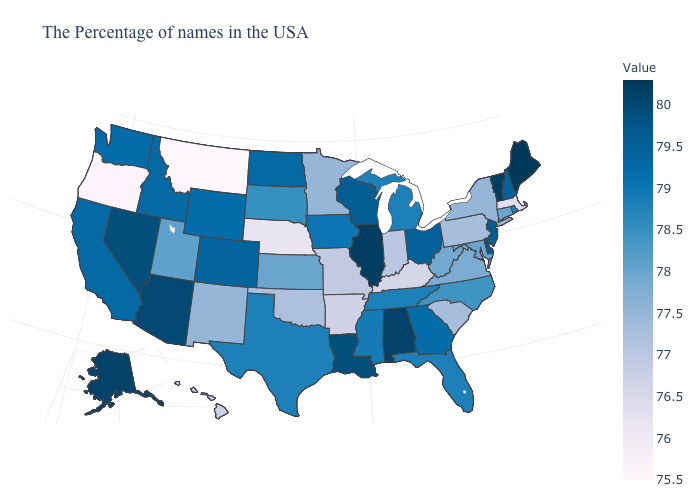Is the legend a continuous bar?
Concise answer only. Yes. Does Maryland have the highest value in the South?
Be succinct. No. Which states hav the highest value in the South?
Write a very short answer. Alabama. Does Ohio have a higher value than Alabama?
Answer briefly. No. Is the legend a continuous bar?
Write a very short answer. Yes. 